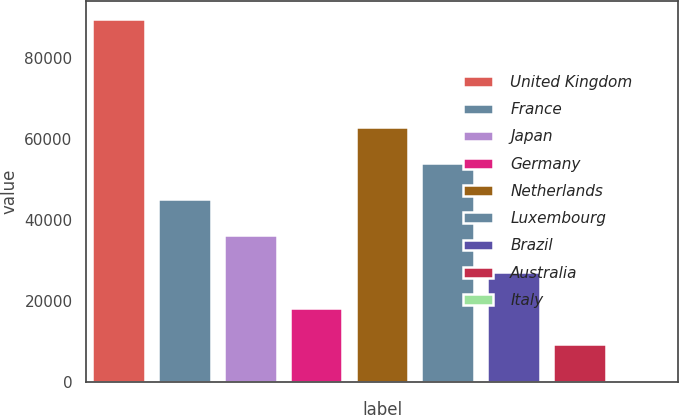<chart> <loc_0><loc_0><loc_500><loc_500><bar_chart><fcel>United Kingdom<fcel>France<fcel>Japan<fcel>Germany<fcel>Netherlands<fcel>Luxembourg<fcel>Brazil<fcel>Australia<fcel>Italy<nl><fcel>89585<fcel>45062<fcel>36157.4<fcel>18348.2<fcel>62871.2<fcel>53966.6<fcel>27252.8<fcel>9443.6<fcel>539<nl></chart> 